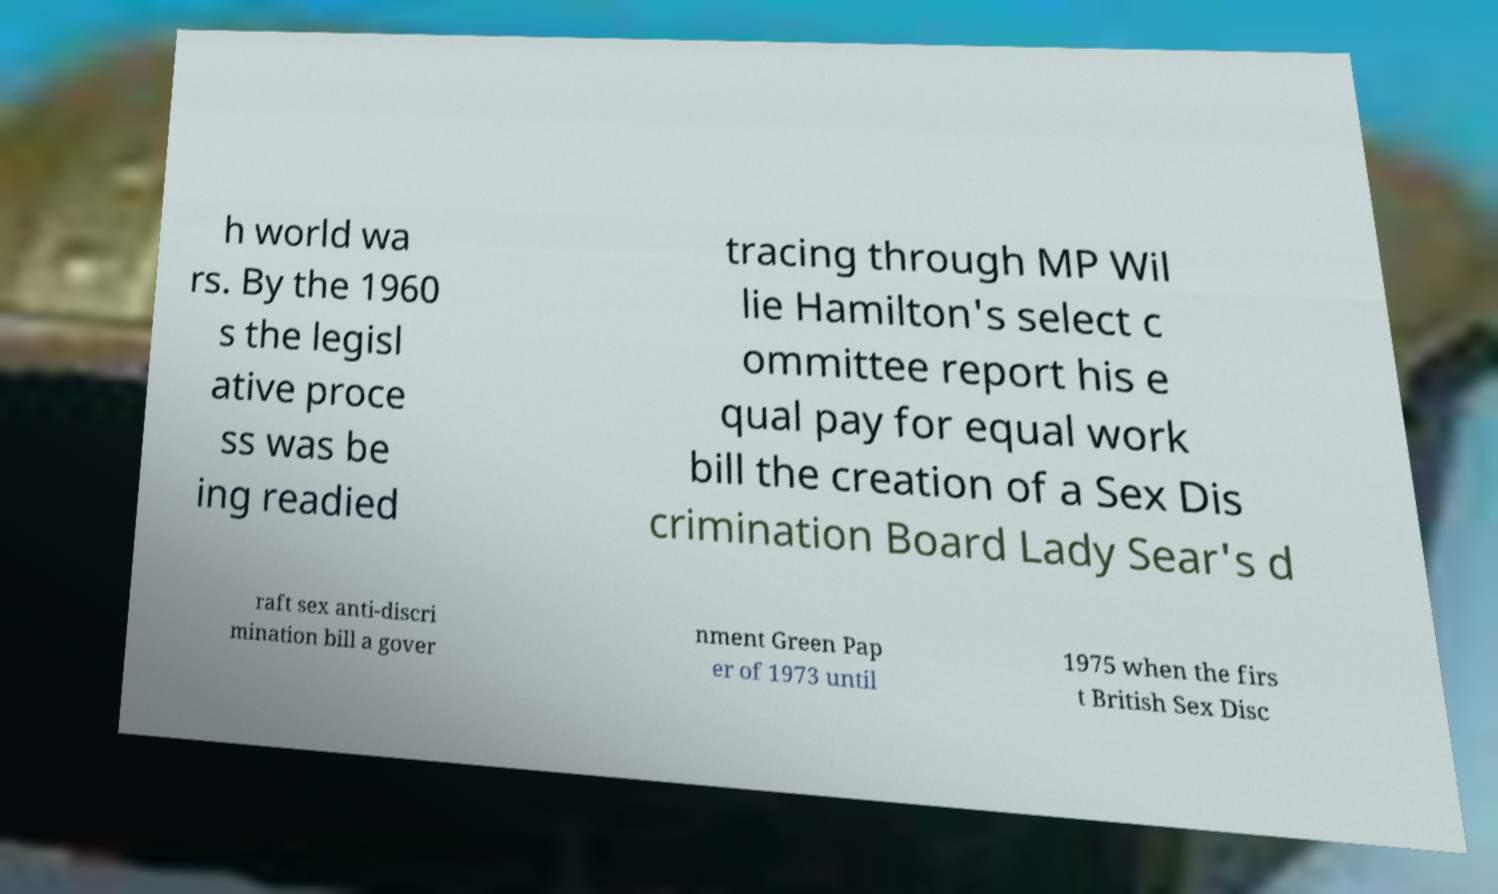What messages or text are displayed in this image? I need them in a readable, typed format. h world wa rs. By the 1960 s the legisl ative proce ss was be ing readied tracing through MP Wil lie Hamilton's select c ommittee report his e qual pay for equal work bill the creation of a Sex Dis crimination Board Lady Sear's d raft sex anti-discri mination bill a gover nment Green Pap er of 1973 until 1975 when the firs t British Sex Disc 